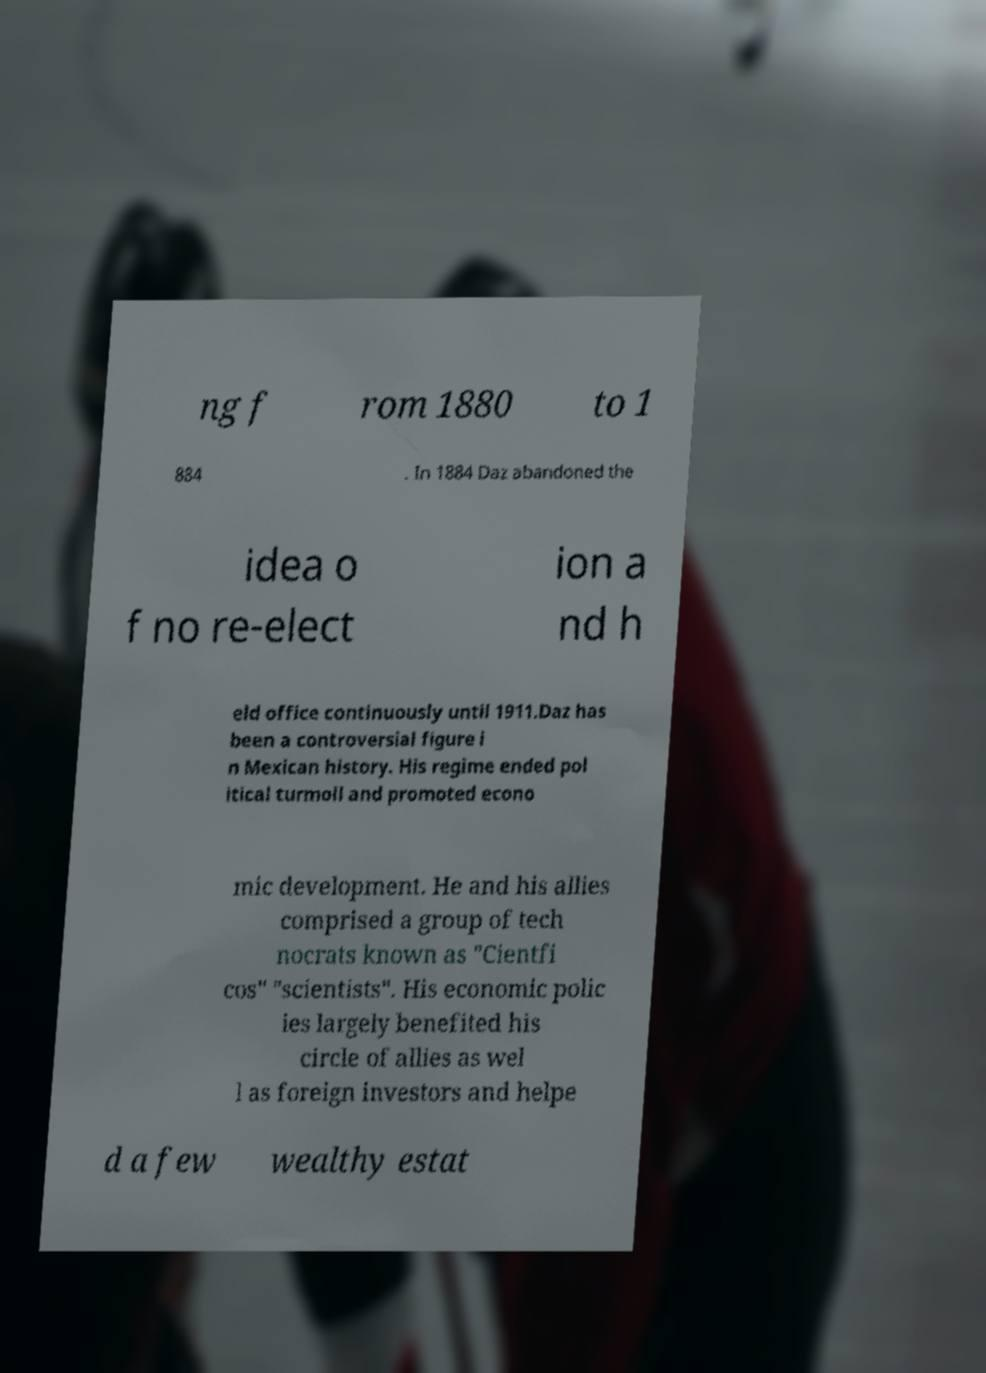Could you assist in decoding the text presented in this image and type it out clearly? ng f rom 1880 to 1 884 . In 1884 Daz abandoned the idea o f no re-elect ion a nd h eld office continuously until 1911.Daz has been a controversial figure i n Mexican history. His regime ended pol itical turmoil and promoted econo mic development. He and his allies comprised a group of tech nocrats known as "Cientfi cos" "scientists". His economic polic ies largely benefited his circle of allies as wel l as foreign investors and helpe d a few wealthy estat 